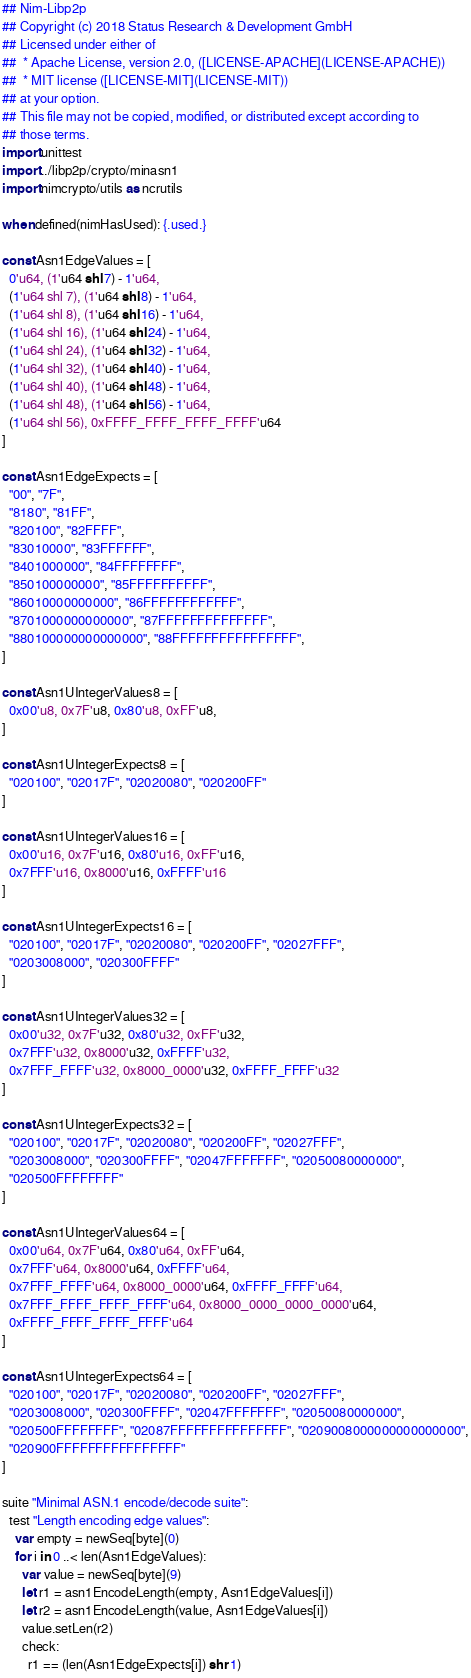Convert code to text. <code><loc_0><loc_0><loc_500><loc_500><_Nim_>## Nim-Libp2p
## Copyright (c) 2018 Status Research & Development GmbH
## Licensed under either of
##  * Apache License, version 2.0, ([LICENSE-APACHE](LICENSE-APACHE))
##  * MIT license ([LICENSE-MIT](LICENSE-MIT))
## at your option.
## This file may not be copied, modified, or distributed except according to
## those terms.
import unittest
import ../libp2p/crypto/minasn1
import nimcrypto/utils as ncrutils

when defined(nimHasUsed): {.used.}

const Asn1EdgeValues = [
  0'u64, (1'u64 shl 7) - 1'u64,
  (1'u64 shl 7), (1'u64 shl 8) - 1'u64,
  (1'u64 shl 8), (1'u64 shl 16) - 1'u64,
  (1'u64 shl 16), (1'u64 shl 24) - 1'u64,
  (1'u64 shl 24), (1'u64 shl 32) - 1'u64,
  (1'u64 shl 32), (1'u64 shl 40) - 1'u64,
  (1'u64 shl 40), (1'u64 shl 48) - 1'u64,
  (1'u64 shl 48), (1'u64 shl 56) - 1'u64,
  (1'u64 shl 56), 0xFFFF_FFFF_FFFF_FFFF'u64
]

const Asn1EdgeExpects = [
  "00", "7F",
  "8180", "81FF",
  "820100", "82FFFF",
  "83010000", "83FFFFFF",
  "8401000000", "84FFFFFFFF",
  "850100000000", "85FFFFFFFFFF",
  "86010000000000", "86FFFFFFFFFFFF",
  "8701000000000000", "87FFFFFFFFFFFFFF",
  "880100000000000000", "88FFFFFFFFFFFFFFFF",
]

const Asn1UIntegerValues8 = [
  0x00'u8, 0x7F'u8, 0x80'u8, 0xFF'u8,
]

const Asn1UIntegerExpects8 = [
  "020100", "02017F", "02020080", "020200FF"
]

const Asn1UIntegerValues16 = [
  0x00'u16, 0x7F'u16, 0x80'u16, 0xFF'u16,
  0x7FFF'u16, 0x8000'u16, 0xFFFF'u16
]

const Asn1UIntegerExpects16 = [
  "020100", "02017F", "02020080", "020200FF", "02027FFF",
  "0203008000", "020300FFFF"
]

const Asn1UIntegerValues32 = [
  0x00'u32, 0x7F'u32, 0x80'u32, 0xFF'u32,
  0x7FFF'u32, 0x8000'u32, 0xFFFF'u32,
  0x7FFF_FFFF'u32, 0x8000_0000'u32, 0xFFFF_FFFF'u32
]

const Asn1UIntegerExpects32 = [
  "020100", "02017F", "02020080", "020200FF", "02027FFF",
  "0203008000", "020300FFFF", "02047FFFFFFF", "02050080000000",
  "020500FFFFFFFF"
]

const Asn1UIntegerValues64 = [
  0x00'u64, 0x7F'u64, 0x80'u64, 0xFF'u64,
  0x7FFF'u64, 0x8000'u64, 0xFFFF'u64,
  0x7FFF_FFFF'u64, 0x8000_0000'u64, 0xFFFF_FFFF'u64,
  0x7FFF_FFFF_FFFF_FFFF'u64, 0x8000_0000_0000_0000'u64,
  0xFFFF_FFFF_FFFF_FFFF'u64
]

const Asn1UIntegerExpects64 = [
  "020100", "02017F", "02020080", "020200FF", "02027FFF",
  "0203008000", "020300FFFF", "02047FFFFFFF", "02050080000000",
  "020500FFFFFFFF", "02087FFFFFFFFFFFFFFF", "0209008000000000000000",
  "020900FFFFFFFFFFFFFFFF"
]

suite "Minimal ASN.1 encode/decode suite":
  test "Length encoding edge values":
    var empty = newSeq[byte](0)
    for i in 0 ..< len(Asn1EdgeValues):
      var value = newSeq[byte](9)
      let r1 = asn1EncodeLength(empty, Asn1EdgeValues[i])
      let r2 = asn1EncodeLength(value, Asn1EdgeValues[i])
      value.setLen(r2)
      check:
        r1 == (len(Asn1EdgeExpects[i]) shr 1)</code> 